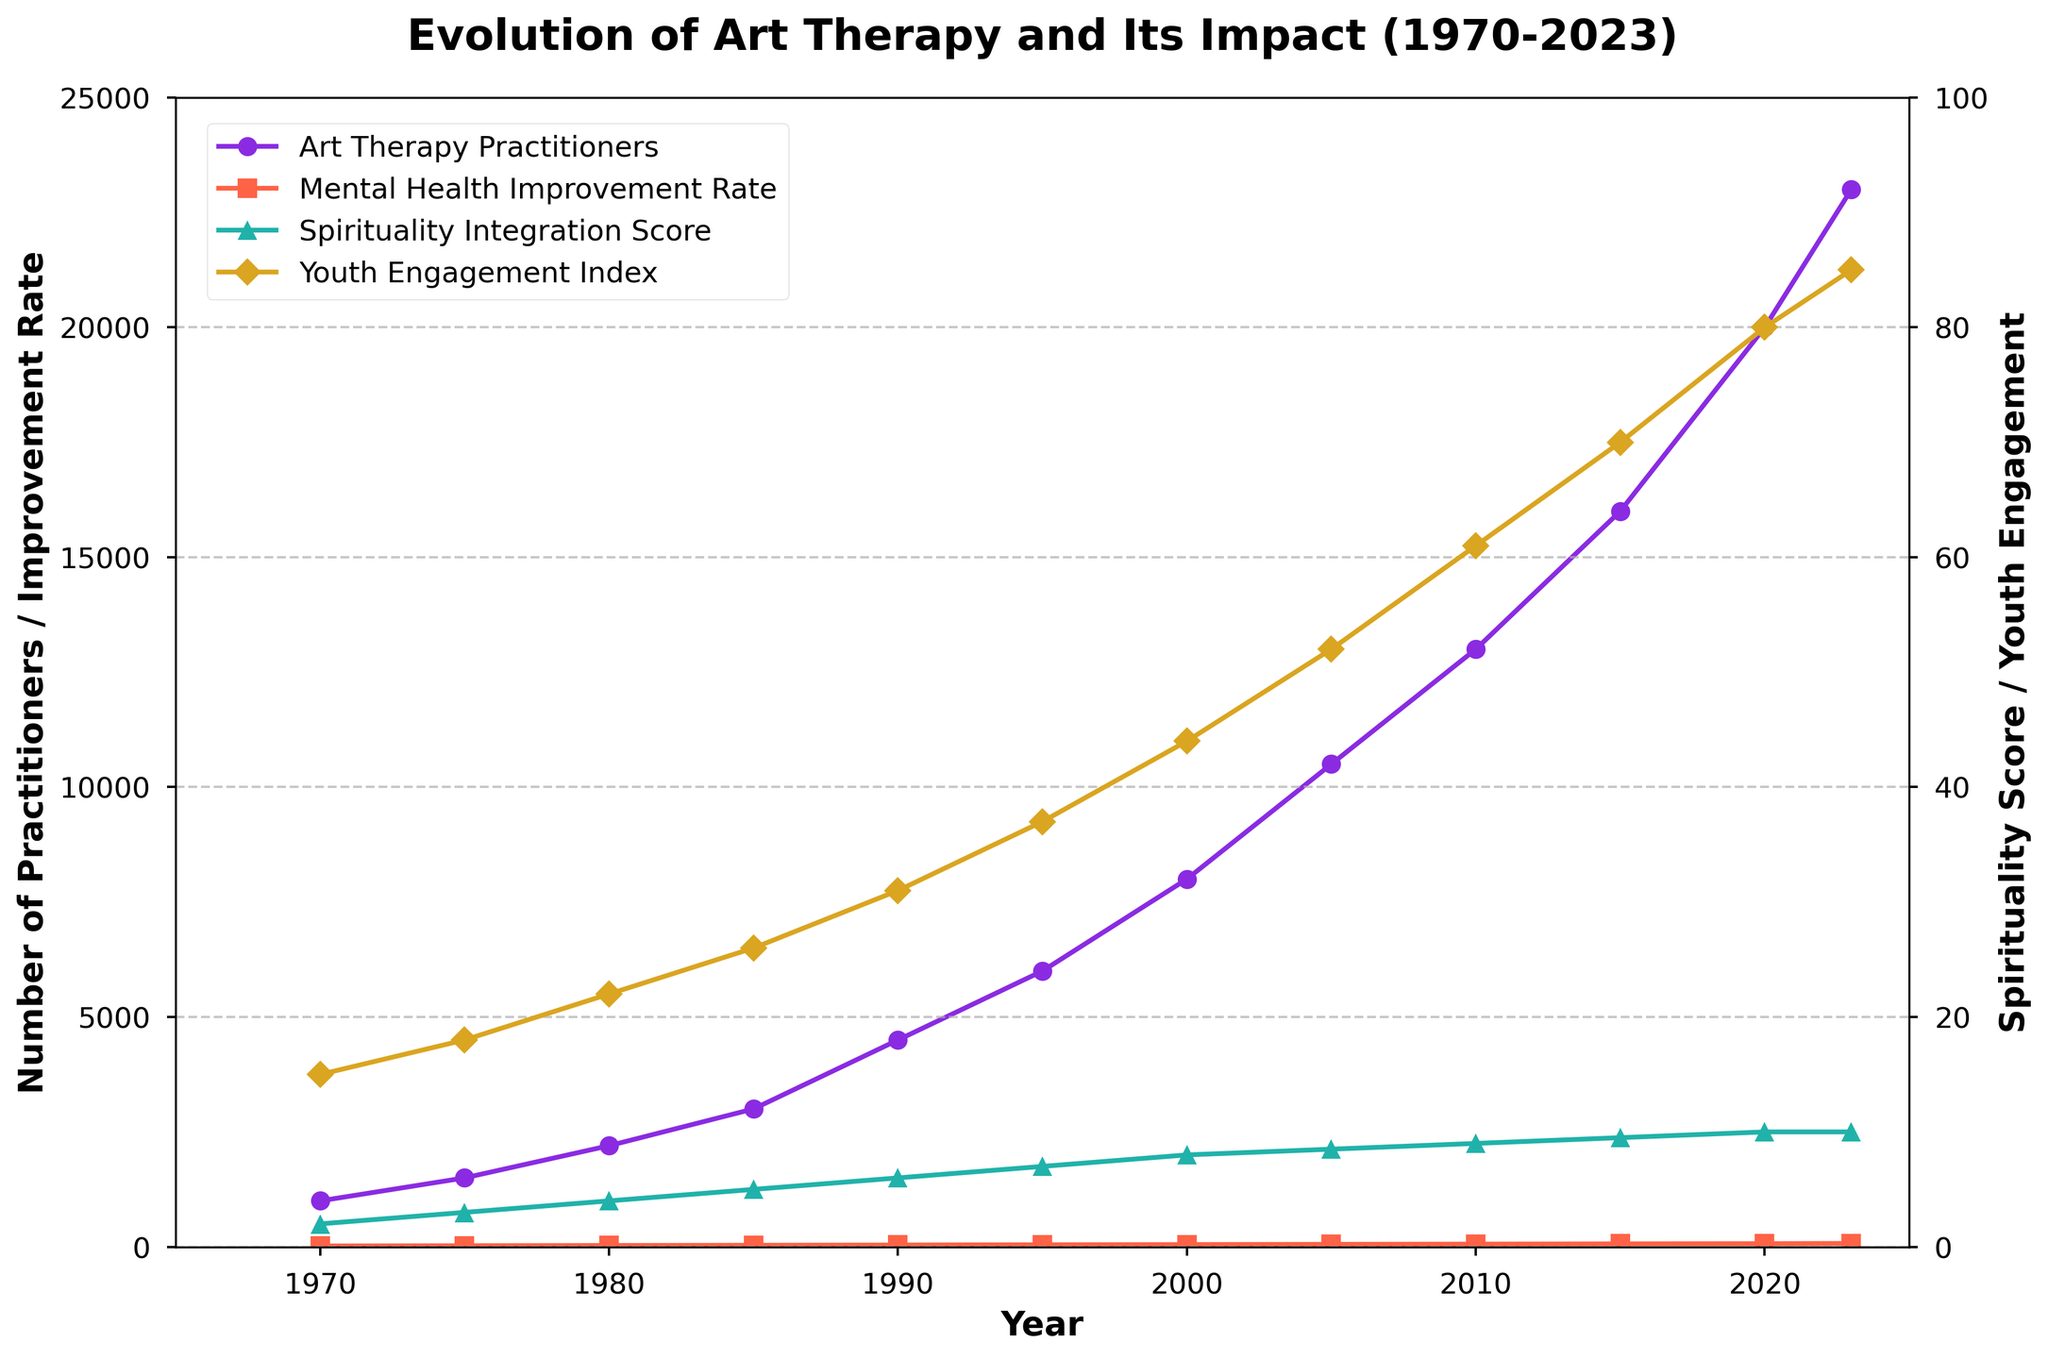What is the overall trend of the number of Art Therapy Practitioners from 1970 to 2023? From the figure, the number of Art Therapy Practitioners shows a continuous upward trend from 1970 to 2023. This indicates a steady increase in the number of practitioners over the years.
Answer: Continuous upward trend In which period did the Mental Health Improvement Rate experience the most significant increase? By visually inspecting the figure, the rate of mental health improvement shows the greatest rise in the period between 2000 and 2005 where it increased from 50 to 55. Prior to this, the increments were relatively smaller.
Answer: 2000 to 2005 How does the Youth Engagement Index in 2023 compare to that in 1970? The Youth Engagement Index increases from 15 in 1970 to 85 in 2023. This represents a significant rise over the period.
Answer: Significantly increased By how many points did the Spirituality Integration Score increase from 1970 to 1990? The Spirituality Integration Score in 1970 is 2 and it increases to 6 in 1990. The difference is calculated as 6 - 2 = 4.
Answer: 4 points Which two years had the greatest difference in the number of Art Therapy Practitioners? The greatest difference in the number of Art Therapy Practitioners occurs between 1970 (1000 practitioners) and 2023 (23000 practitioners). The difference is 23000 - 1000 = 22000.
Answer: 1970 and 2023 How did the Spirituality Integration Score change between 2005 and 2010? The score increased from 8.5 in 2005 to 9 in 2010. Therefore, it increased by 0.5 points during this period.
Answer: Increased by 0.5 points At which point does the Mental Health Improvement Rate reach 50? The Mental Health Improvement Rate reaches 50 in the year 2000. This is identified by locating the line for Mental Health Improvement Rate intersecting with the 50-mark on the y-axis.
Answer: Year 2000 Compare the height of the Mental Health Improvement Rate line in 1995 and the Youth Engagement Index line in 2023. Which is higher? The Mental Health Improvement Rate in 1995 is 45, while the Youth Engagement Index in 2023 is 85. Consequently, the Youth Engagement Index line in 2023 is higher.
Answer: Youth Engagement Index in 2023 What is the average Mental Health Improvement Rate across all the years shown? To calculate the average, add all the Mental Health Improvement Rates and divide by the number of years: (20 + 25 + 30 + 35 + 40 + 45 + 50 + 55 + 60 + 65 + 70 + 75) / 12 = 570 / 12 = 47.5.
Answer: 47.5 